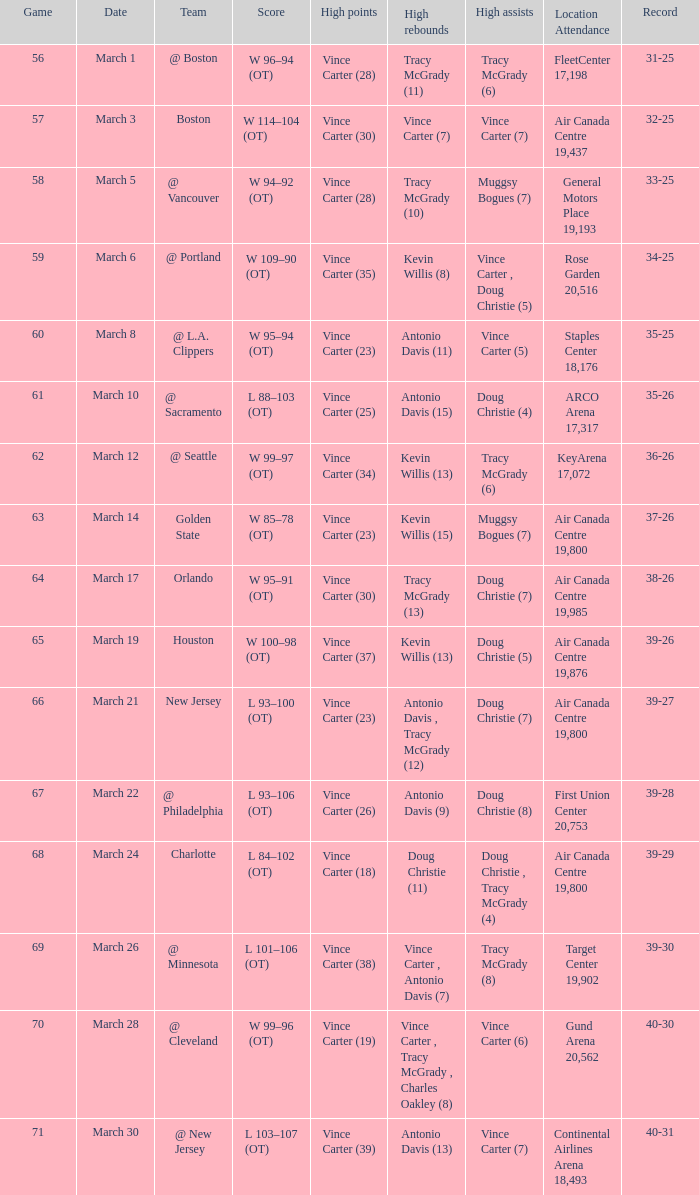In the match against charlotte, who recorded the highest rebounds? Doug Christie (11). 